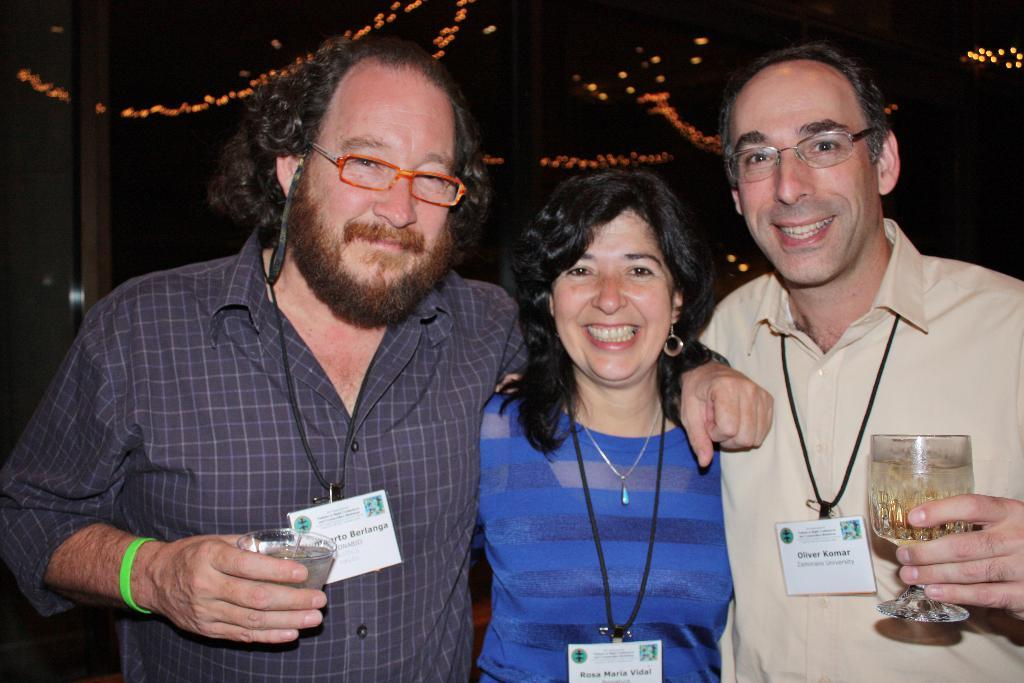How many people are in the image? There are three persons in the image. What are the persons holding in their hands? The persons are holding glasses in their hands. What can be seen in the background of the image? There are lights and a wall in the background of the image. Can you describe the possible setting of the image? The image may have been taken in a restaurant. What type of kite is being flown by the person in the middle of the image? There is no kite present in the image; the persons are holding glasses in their hands. How does the power of the lights affect the mood of the image? The image does not provide information about the power of the lights or their effect on the mood. 